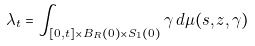<formula> <loc_0><loc_0><loc_500><loc_500>\lambda _ { t } = \int _ { [ 0 , t ] \times { B _ { R } ( 0 ) } \times S _ { 1 } ( 0 ) } \gamma \, d \mu ( s , z , \gamma )</formula> 